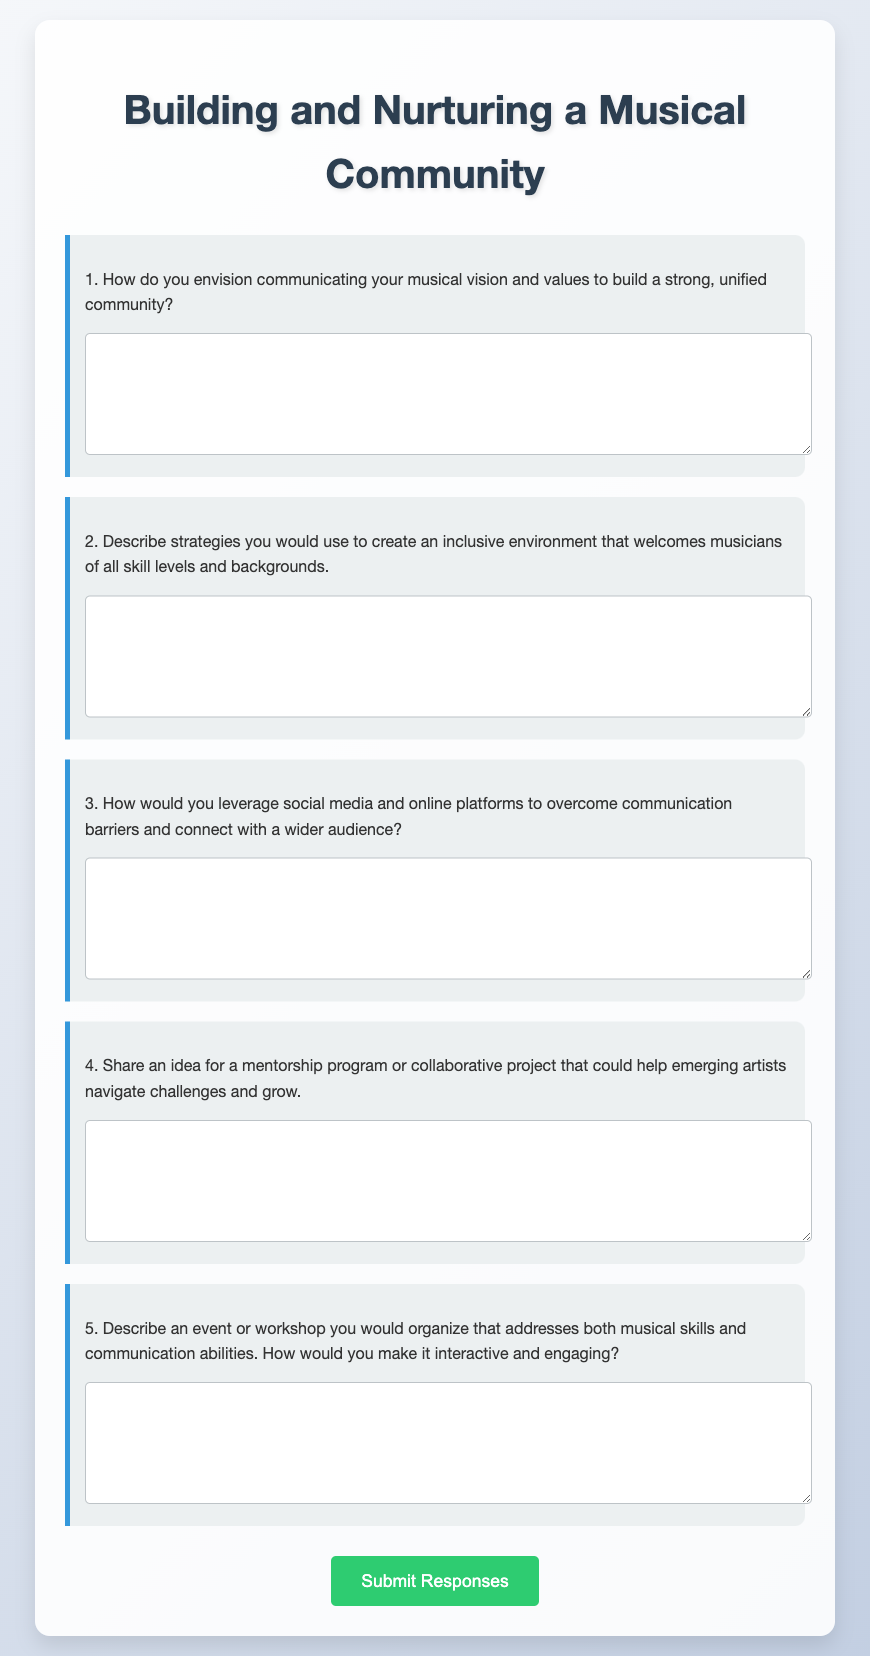What is the title of the document? The title is presented at the top of the document, which serves as the main identifier for its content.
Answer: Building and Nurturing a Musical Community How many questions are there in the questionnaire? The number of questions is indicated by the listed items within the questionnaire form.
Answer: 5 What is the main action encouraged at the end of the document? The main action is shown by a button that encourages participants to complete and submit their insights.
Answer: Submit Responses What color is used for the submit button? The color of the submit button is specified in the style section of the document.
Answer: Green What type of questions are primarily used in the document? The questionnaire specifically emphasizes a type of question designed for participants to provide detailed input.
Answer: Short-answer questions Which question focuses on creating an inclusive environment? The specific question addressing inclusivity is framed within the context of welcoming different musicians.
Answer: Describe strategies you would use to create an inclusive environment that welcomes musicians of all skill levels and backgrounds What feature enhances the visibility of the questions? The design includes a distinctive border style that highlights each question in the form.
Answer: A solid border on the left side What is the purpose of the script at the end of the document? The script serves a functional role by providing feedback once the questionnaire is submitted.
Answer: To show a thank you message after submission 